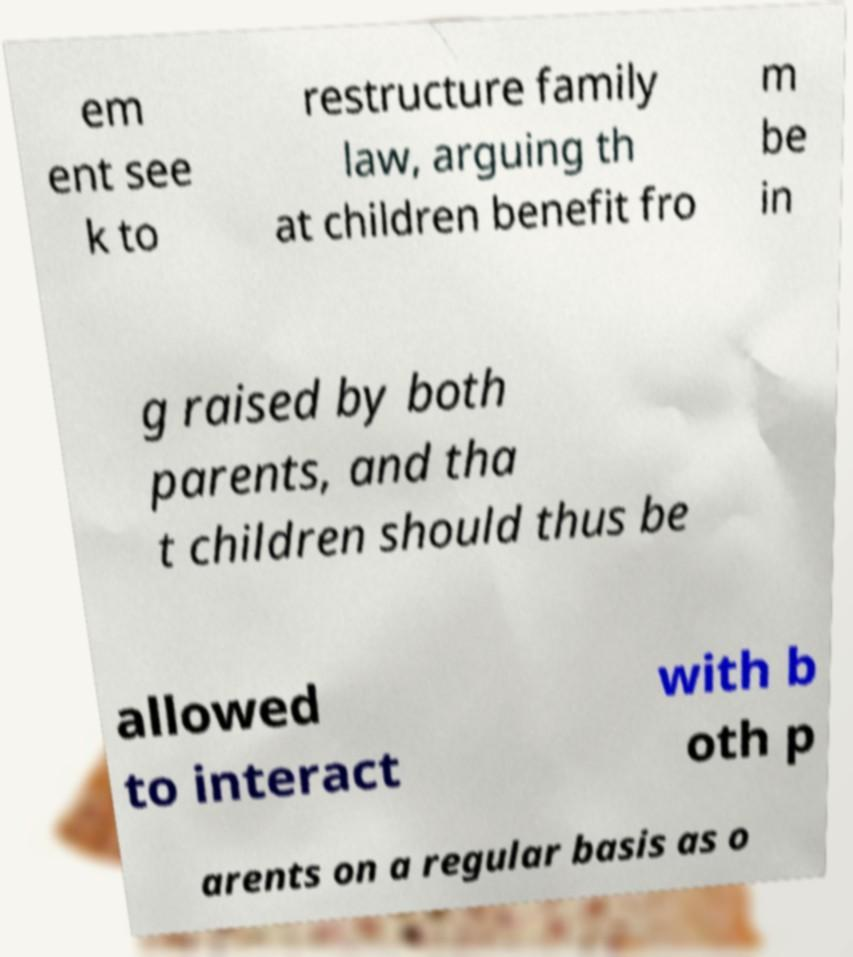Please read and relay the text visible in this image. What does it say? em ent see k to restructure family law, arguing th at children benefit fro m be in g raised by both parents, and tha t children should thus be allowed to interact with b oth p arents on a regular basis as o 